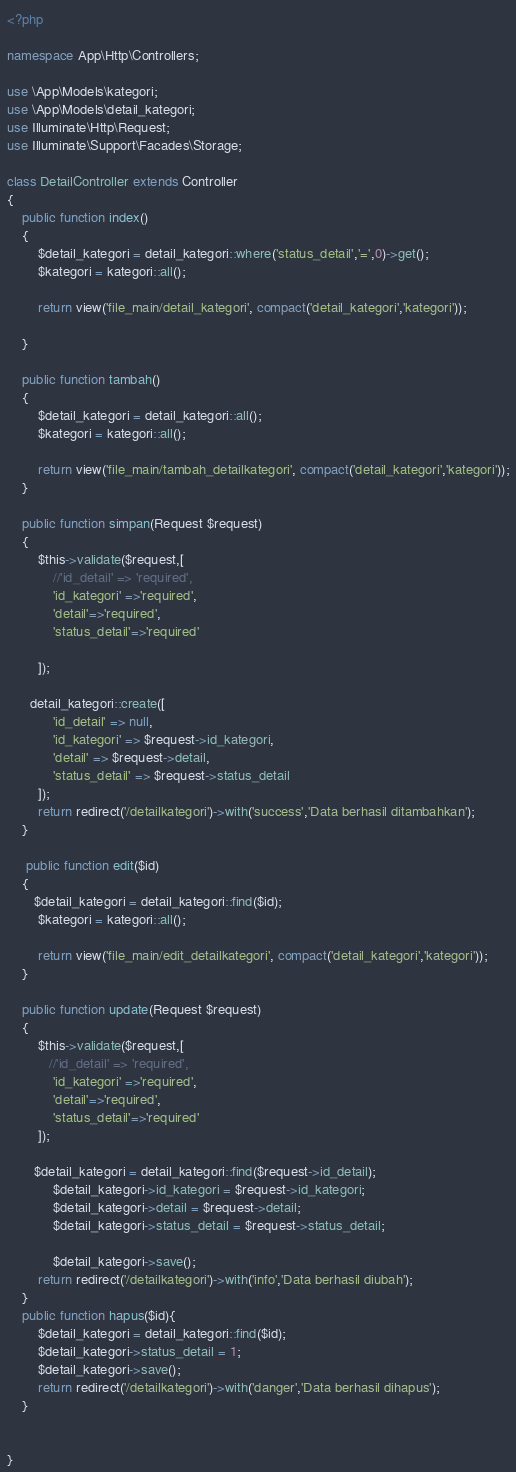<code> <loc_0><loc_0><loc_500><loc_500><_PHP_><?php

namespace App\Http\Controllers;

use \App\Models\kategori;
use \App\Models\detail_kategori;
use Illuminate\Http\Request;
use Illuminate\Support\Facades\Storage;

class DetailController extends Controller
{
    public function index()
    {
    	$detail_kategori = detail_kategori::where('status_detail','=',0)->get();
        $kategori = kategori::all();

        return view('file_main/detail_kategori', compact('detail_kategori','kategori'));
       
    }

    public function tambah()
    {
    	$detail_kategori = detail_kategori::all();
        $kategori = kategori::all();

        return view('file_main/tambah_detailkategori', compact('detail_kategori','kategori'));
    }

    public function simpan(Request $request)
    {
        $this->validate($request,[
            //'id_detail' => 'required',
            'id_kategori' =>'required',
            'detail'=>'required',
            'status_detail'=>'required'

        ]);

      detail_kategori::create([
            'id_detail' => null,
            'id_kategori' => $request->id_kategori,
            'detail' => $request->detail,
            'status_detail' => $request->status_detail
        ]);
        return redirect('/detailkategori')->with('success','Data berhasil ditambahkan');
    }

     public function edit($id)
    {
       $detail_kategori = detail_kategori::find($id);
        $kategori = kategori::all();

        return view('file_main/edit_detailkategori', compact('detail_kategori','kategori'));
    }

    public function update(Request $request)
    {
        $this->validate($request,[
           //'id_detail' => 'required',
            'id_kategori' =>'required',
            'detail'=>'required',
            'status_detail'=>'required'
        ]);

       $detail_kategori = detail_kategori::find($request->id_detail);
            $detail_kategori->id_kategori = $request->id_kategori;
            $detail_kategori->detail = $request->detail;
            $detail_kategori->status_detail = $request->status_detail;
            
            $detail_kategori->save();
        return redirect('/detailkategori')->with('info','Data berhasil diubah');
    }
    public function hapus($id){
        $detail_kategori = detail_kategori::find($id);
        $detail_kategori->status_detail = 1;
        $detail_kategori->save();
        return redirect('/detailkategori')->with('danger','Data berhasil dihapus');
    }


}
</code> 